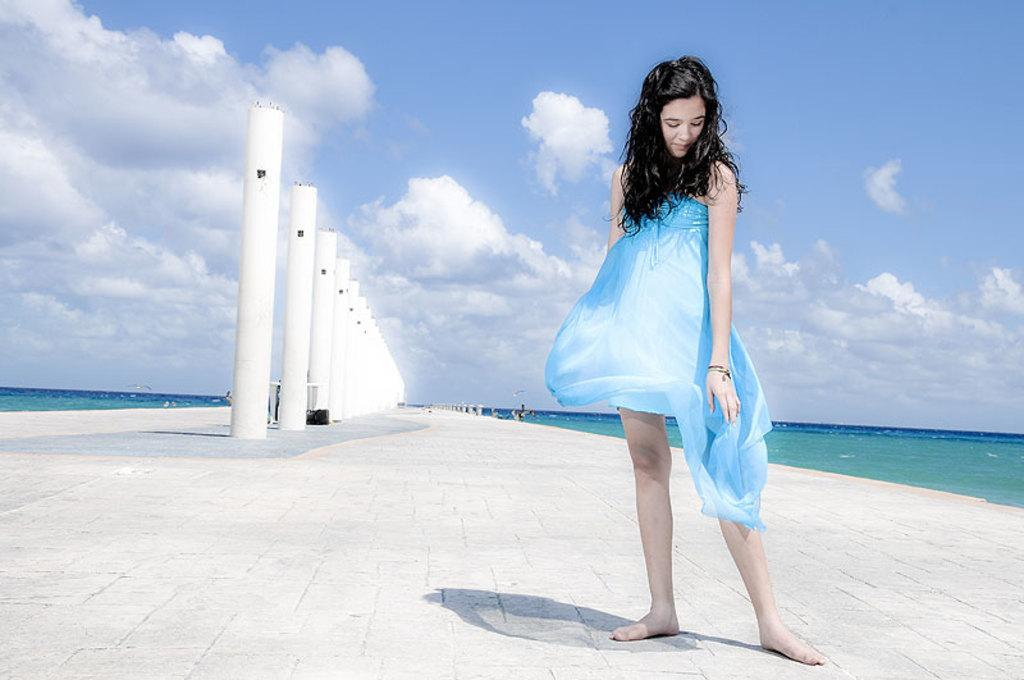What can be seen in the sky in the image? The sky with clouds is visible in the image. What architectural features are present in the image? There are pillars in the image. What natural feature is present in the image? The ocean is present in the image. What structures are used to separate or protect areas in the image? There are barriers in the image. What is the woman in the image doing? The woman is standing on a walkway bridge in the image. How does the woman compare the taste of a bean to a quarter in the image? There is no mention of beans or quarters in the image; the focus is on the sky, pillars, ocean, barriers, and the woman standing on a walkway bridge. 